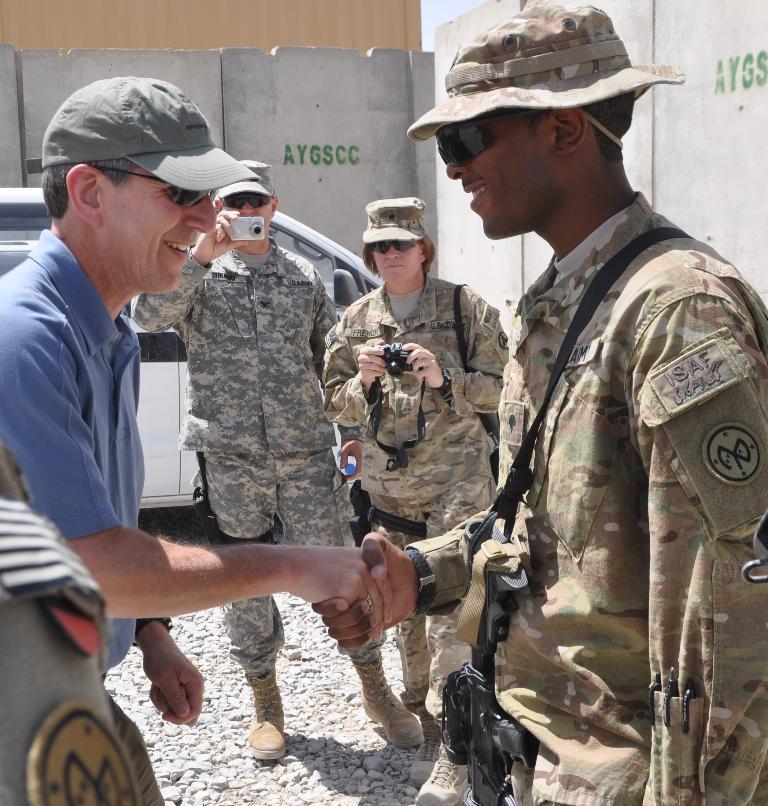Can you describe this image briefly? In this image there are two persons standing and handshaking each other, and in the background there are two persons standing and holding the cameras , a white color car, wall. 